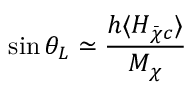<formula> <loc_0><loc_0><loc_500><loc_500>\sin \theta _ { L } \simeq \frac { h \langle H _ { \bar { \chi } c } \rangle } { M _ { \chi } }</formula> 